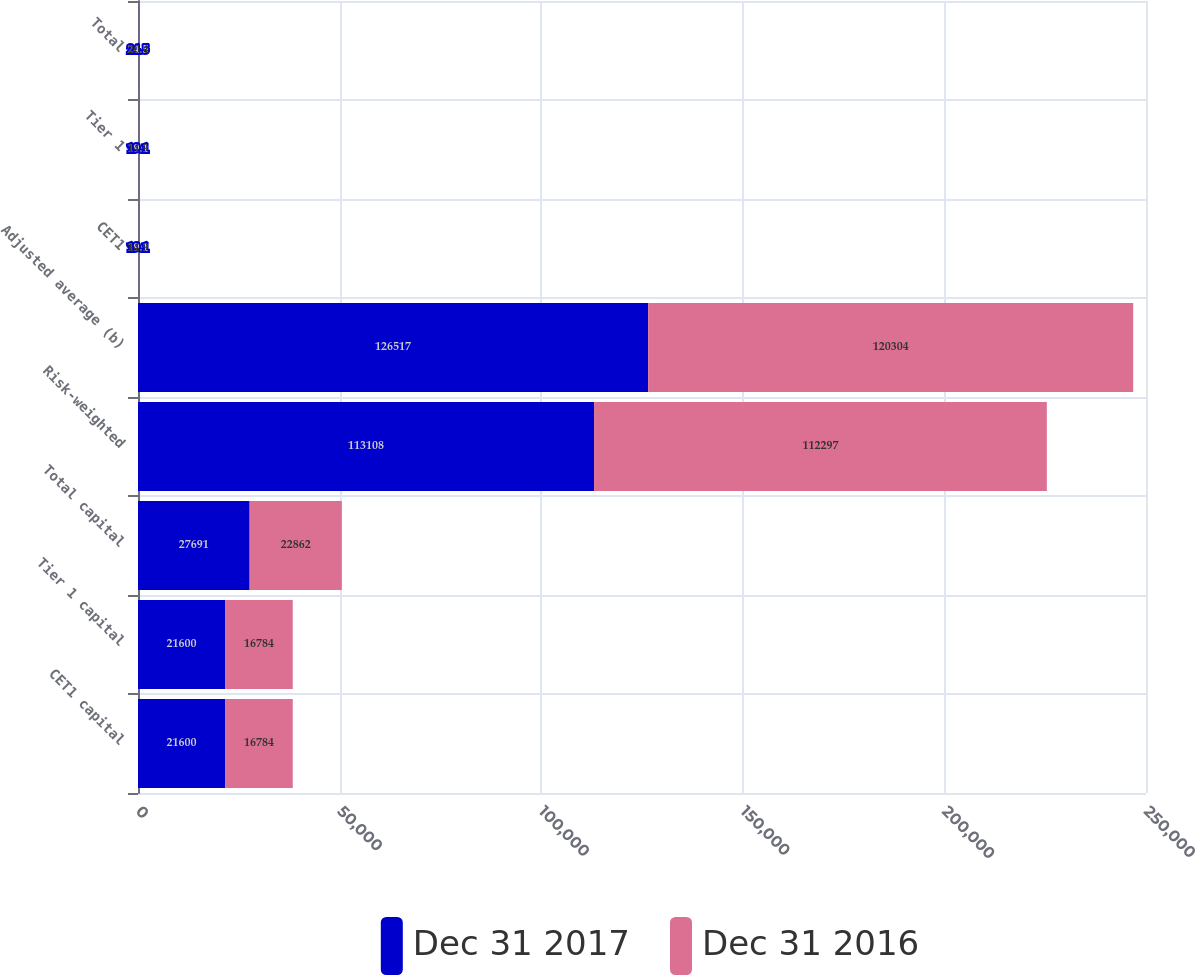Convert chart. <chart><loc_0><loc_0><loc_500><loc_500><stacked_bar_chart><ecel><fcel>CET1 capital<fcel>Tier 1 capital<fcel>Total capital<fcel>Risk-weighted<fcel>Adjusted average (b)<fcel>CET1<fcel>Tier 1<fcel>Total<nl><fcel>Dec 31 2017<fcel>21600<fcel>21600<fcel>27691<fcel>113108<fcel>126517<fcel>19.1<fcel>19.1<fcel>24.5<nl><fcel>Dec 31 2016<fcel>16784<fcel>16784<fcel>22862<fcel>112297<fcel>120304<fcel>14.9<fcel>14.9<fcel>20.4<nl></chart> 